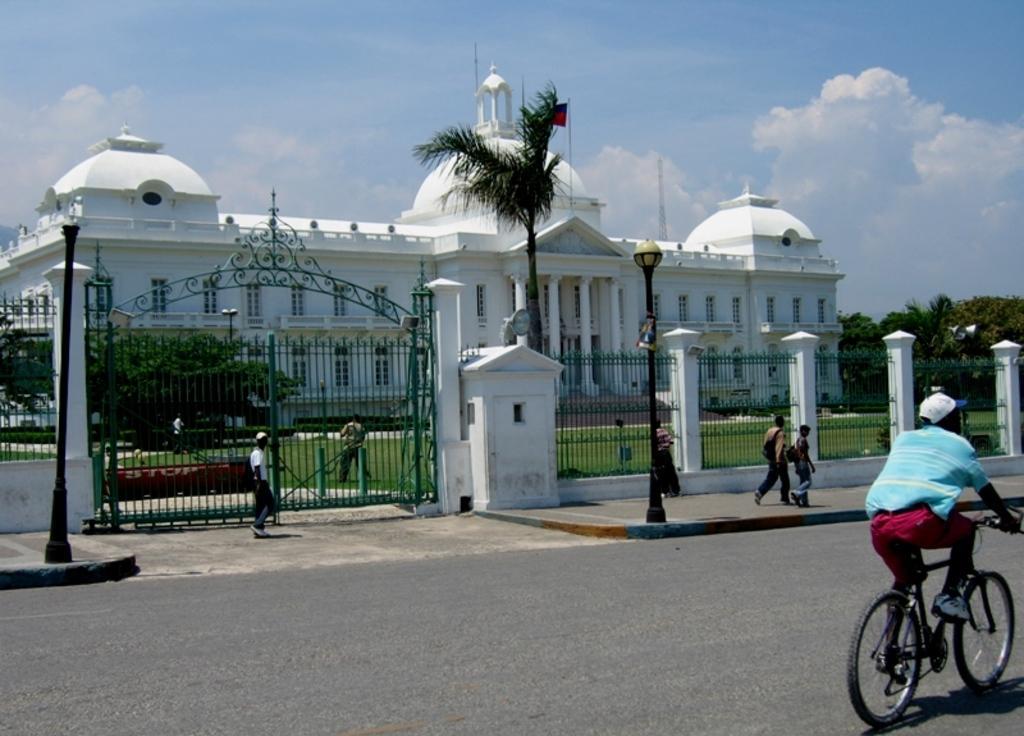Could you give a brief overview of what you see in this image? In this image we can see a person wearing blue color T-shirt riding bicycle and there are some persons walking through the footpath and in the background of the image there is gate, fencing and there is a place, there are some trees and top of the image there is clear sky. 